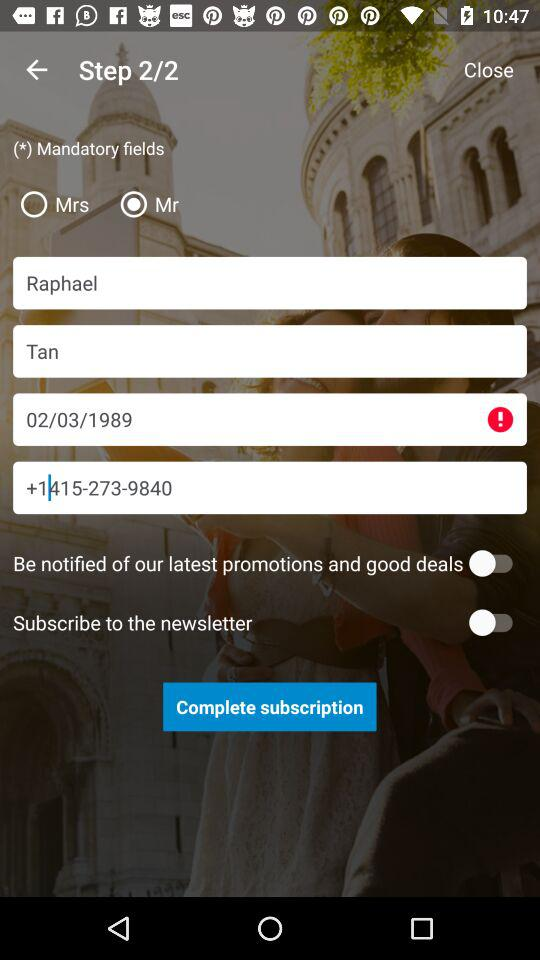How many steps are there? There are two steps. 